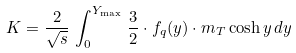<formula> <loc_0><loc_0><loc_500><loc_500>K = \frac { 2 } { \sqrt { s } } \, \int ^ { Y _ { \max } } _ { 0 } \, \frac { 3 } { 2 } \cdot f _ { q } ( y ) \cdot m _ { T } \cosh y \, d y</formula> 